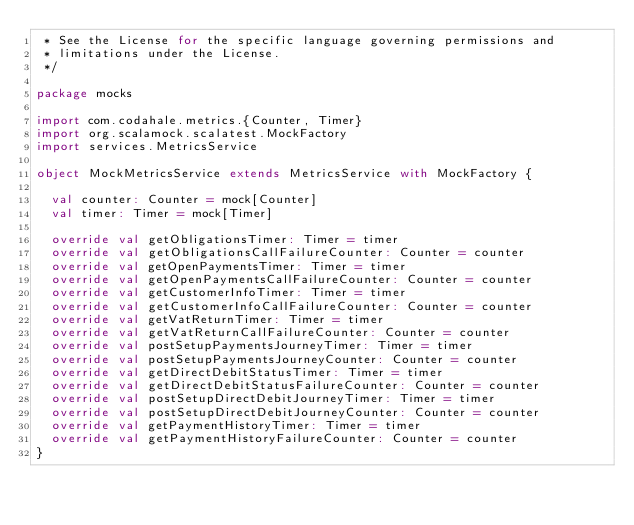Convert code to text. <code><loc_0><loc_0><loc_500><loc_500><_Scala_> * See the License for the specific language governing permissions and
 * limitations under the License.
 */

package mocks

import com.codahale.metrics.{Counter, Timer}
import org.scalamock.scalatest.MockFactory
import services.MetricsService

object MockMetricsService extends MetricsService with MockFactory {

  val counter: Counter = mock[Counter]
  val timer: Timer = mock[Timer]

  override val getObligationsTimer: Timer = timer
  override val getObligationsCallFailureCounter: Counter = counter
  override val getOpenPaymentsTimer: Timer = timer
  override val getOpenPaymentsCallFailureCounter: Counter = counter
  override val getCustomerInfoTimer: Timer = timer
  override val getCustomerInfoCallFailureCounter: Counter = counter
  override val getVatReturnTimer: Timer = timer
  override val getVatReturnCallFailureCounter: Counter = counter
  override val postSetupPaymentsJourneyTimer: Timer = timer
  override val postSetupPaymentsJourneyCounter: Counter = counter
  override val getDirectDebitStatusTimer: Timer = timer
  override val getDirectDebitStatusFailureCounter: Counter = counter
  override val postSetupDirectDebitJourneyTimer: Timer = timer
  override val postSetupDirectDebitJourneyCounter: Counter = counter
  override val getPaymentHistoryTimer: Timer = timer
  override val getPaymentHistoryFailureCounter: Counter = counter
}
</code> 